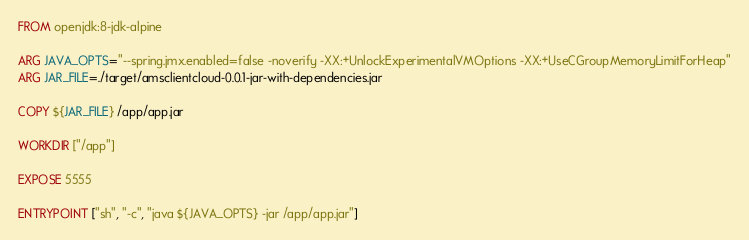<code> <loc_0><loc_0><loc_500><loc_500><_Dockerfile_>FROM openjdk:8-jdk-alpine

ARG JAVA_OPTS="--spring.jmx.enabled=false -noverify -XX:+UnlockExperimentalVMOptions -XX:+UseCGroupMemoryLimitForHeap"
ARG JAR_FILE=./target/amsclientcloud-0.0.1-jar-with-dependencies.jar

COPY ${JAR_FILE} /app/app.jar

WORKDIR ["/app"]

EXPOSE 5555

ENTRYPOINT ["sh", "-c", "java ${JAVA_OPTS} -jar /app/app.jar"]</code> 